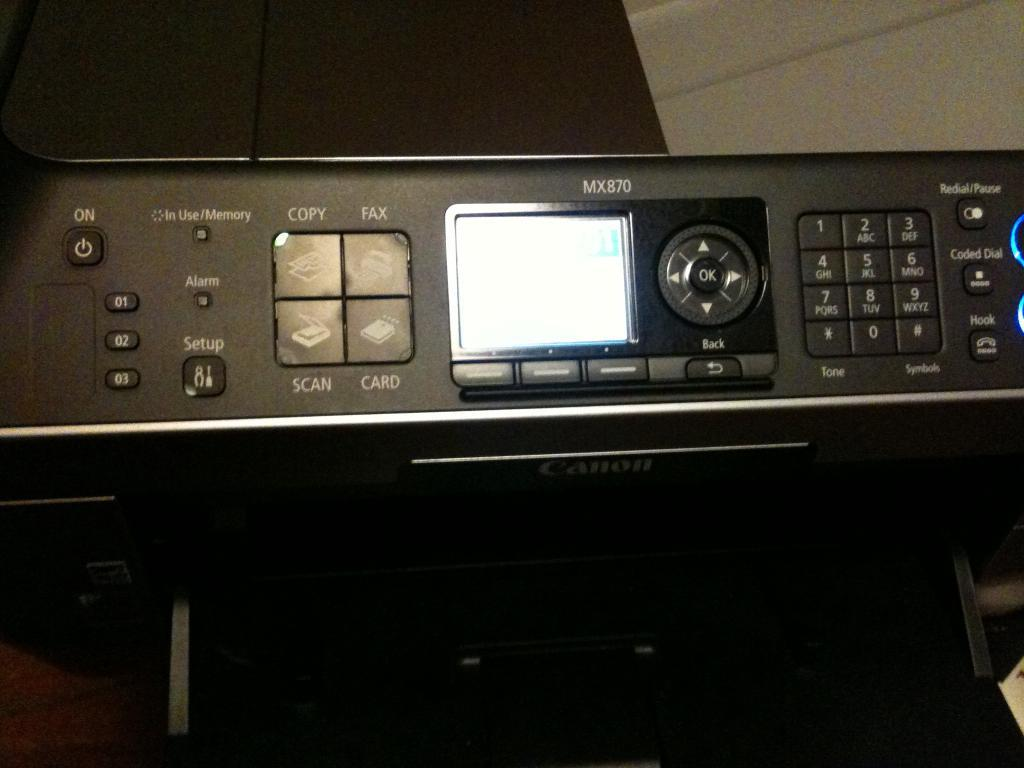What type of object is present in the image? There is an electronic device in the image. What feature does the electronic device have? The electronic device has buttons. Can you describe the lighting in the image? The image is dark. How many kitties are playing with the electronic device in the image? There are no kitties present in the image; it only features an electronic device with buttons. What type of pigs can be seen interacting with the electronic device in the image? There are no pigs present in the image; it only features an electronic device with buttons. 